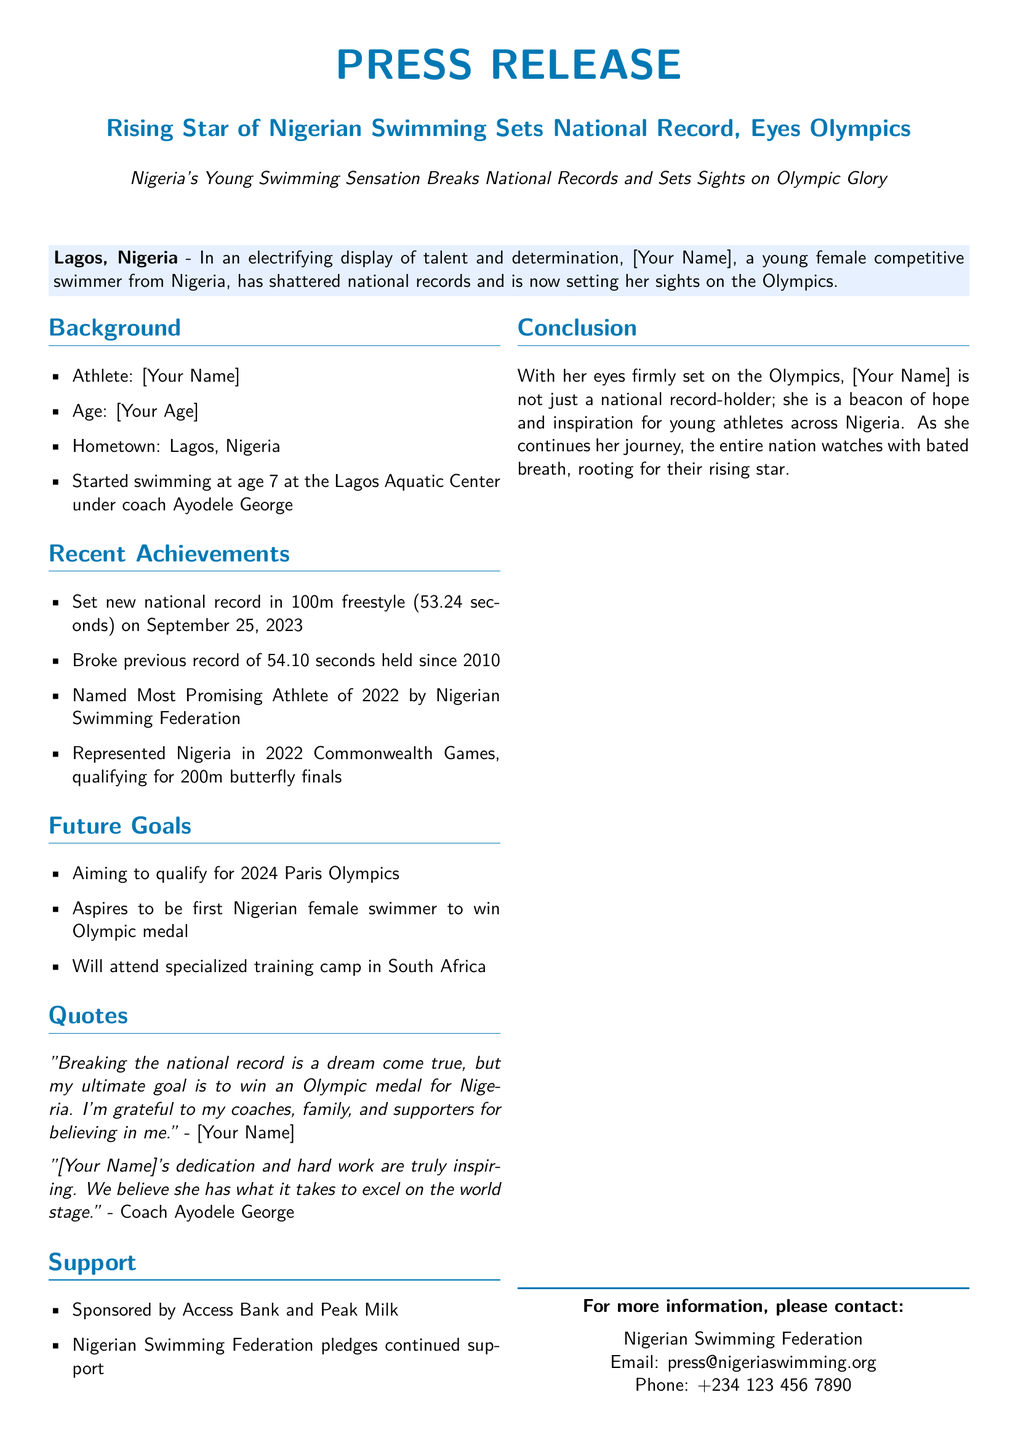What is the name of the athlete? The name of the athlete is mentioned at the beginning of the document and is "[Your Name]."
Answer: [Your Name] What age did the athlete start swimming? The document states that the athlete started swimming at age 7.
Answer: 7 What is the new national record time in the 100m freestyle? The document provides the new national record time as 53.24 seconds.
Answer: 53.24 seconds Who is the coach of the athlete? The coach's name is mentioned in the document as Ayodele George.
Answer: Ayodele George What major sporting event did the athlete represent Nigeria in? The athlete represented Nigeria in the 2022 Commonwealth Games, as stated in the document.
Answer: 2022 Commonwealth Games What is the athlete's ultimate goal? The document indicates that the athlete's ultimate goal is to win an Olympic medal for Nigeria.
Answer: Olympic medal Which sponsors support the athlete? The document lists the sponsors as Access Bank and Peak Milk.
Answer: Access Bank and Peak Milk What does the athlete plan to attend for training? The athlete plans to attend a specialized training camp in South Africa according to the document.
Answer: specialized training camp in South Africa What recognition did the athlete receive from the Nigerian Swimming Federation? The document states that the athlete was named the Most Promising Athlete of 2022.
Answer: Most Promising Athlete of 2022 